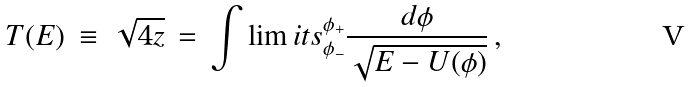<formula> <loc_0><loc_0><loc_500><loc_500>T ( E ) \, \equiv \, \sqrt { 4 z } \, = \, \int \lim i t s _ { \phi _ { - } } ^ { \phi _ { + } } \frac { d \phi } { \sqrt { E - U ( \phi ) } } \, ,</formula> 